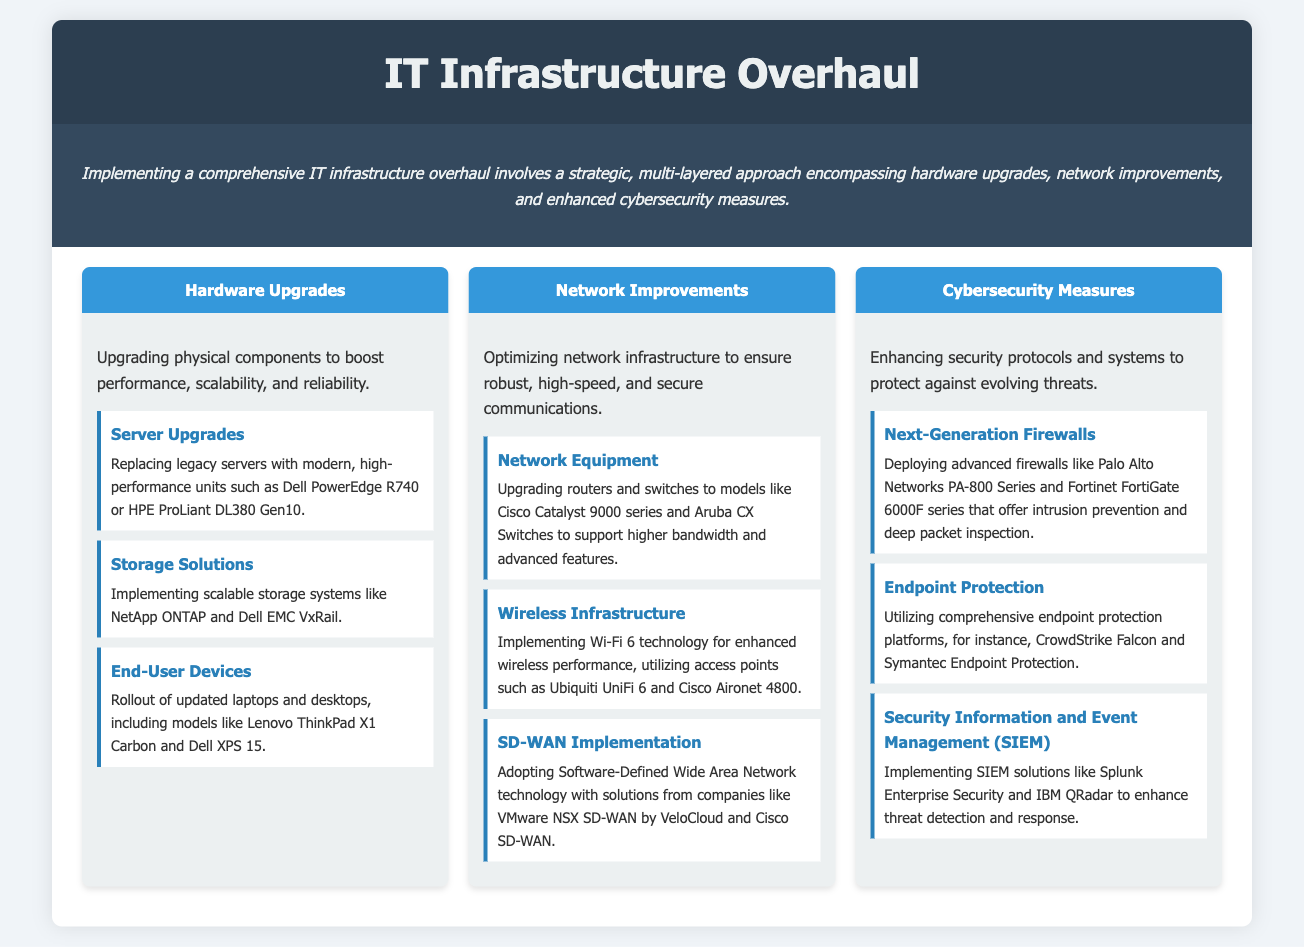what are the main categories of the IT infrastructure overhaul? The document lists three main categories: hardware upgrades, network improvements, and cybersecurity measures.
Answer: hardware upgrades, network improvements, cybersecurity measures which server model is mentioned for upgrades? The document specifies Dell PowerEdge R740 as a recommended server model for upgrades.
Answer: Dell PowerEdge R740 what technology is recommended for wireless infrastructure? The document suggests implementing Wi-Fi 6 technology for enhanced wireless performance.
Answer: Wi-Fi 6 name one endpoint protection platform mentioned. The document lists CrowdStrike Falcon as one of the comprehensive endpoint protection platforms.
Answer: CrowdStrike Falcon what is the role of SIEM in the IT infrastructure overhaul? SIEM solutions enhance threat detection and response as mentioned in the cybersecurity measures section.
Answer: enhance threat detection and response how many components are listed under hardware upgrades? The document outlines three components related to hardware upgrades: server upgrades, storage solutions, and end-user devices.
Answer: three what type of technology does the document recommend for network optimization? It mentions adopting Software-Defined Wide Area Network (SD-WAN) technology for network optimization.
Answer: SD-WAN which brand provides a next-generation firewall solution mentioned? The document refers to Palo Alto Networks for next-generation firewalls.
Answer: Palo Alto Networks what is a key component of endpoint protection mentioned? The document states that the other comprehensive endpoint protection platform mentioned is Symantec Endpoint Protection.
Answer: Symantec Endpoint Protection 